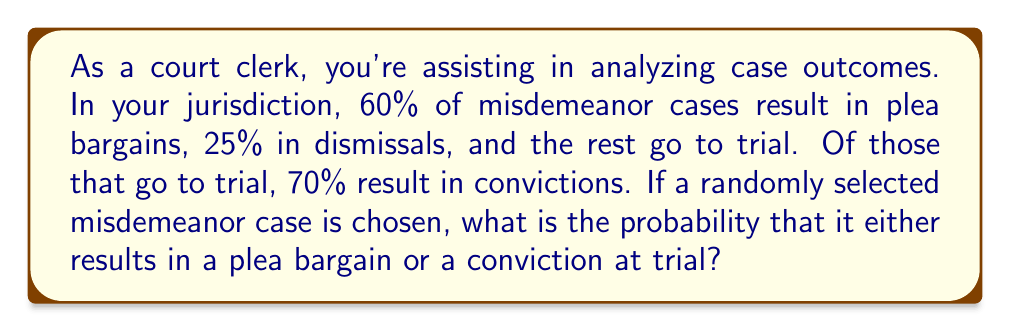Can you answer this question? Let's approach this step-by-step:

1) First, let's identify the probabilities we know:
   - Probability of plea bargain: 60% = 0.60
   - Probability of dismissal: 25% = 0.25
   - Probability of going to trial: 100% - 60% - 25% = 15% = 0.15

2) For cases that go to trial, 70% result in convictions:
   - Probability of conviction given that it went to trial: 70% = 0.70

3) We need to find the probability of either a plea bargain OR a conviction at trial. This is the sum of:
   a) Probability of plea bargain
   b) Probability of conviction at trial

4) We already know (a). For (b), we need to calculate:
   (Probability of going to trial) × (Probability of conviction given that it went to trial)

   $$ P(\text{conviction at trial}) = 0.15 \times 0.70 = 0.105 $$

5) Now, we can sum the probabilities:

   $$ P(\text{plea bargain or conviction at trial}) = P(\text{plea bargain}) + P(\text{conviction at trial}) $$
   $$ = 0.60 + 0.105 = 0.705 $$

6) Convert to a percentage:
   $$ 0.705 \times 100\% = 70.5\% $$
Answer: The probability that a randomly selected misdemeanor case results in either a plea bargain or a conviction at trial is 70.5%. 